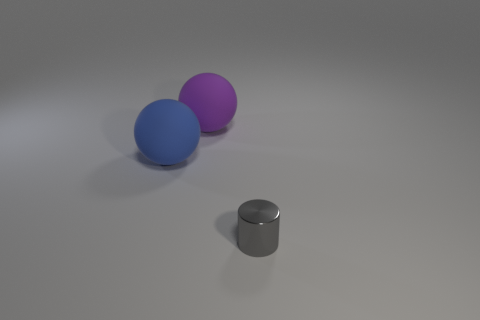Subtract all green cylinders. Subtract all yellow cubes. How many cylinders are left? 1 Add 3 large rubber balls. How many objects exist? 6 Subtract all balls. How many objects are left? 1 Subtract 1 gray cylinders. How many objects are left? 2 Subtract all small purple metal cubes. Subtract all gray metallic cylinders. How many objects are left? 2 Add 3 small gray cylinders. How many small gray cylinders are left? 4 Add 1 small gray cylinders. How many small gray cylinders exist? 2 